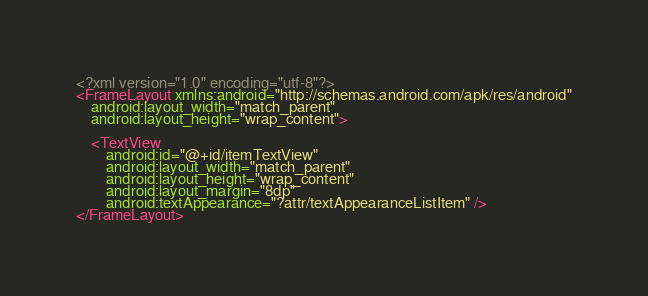Convert code to text. <code><loc_0><loc_0><loc_500><loc_500><_XML_><?xml version="1.0" encoding="utf-8"?>
<FrameLayout xmlns:android="http://schemas.android.com/apk/res/android"
    android:layout_width="match_parent"
    android:layout_height="wrap_content">

    <TextView
        android:id="@+id/itemTextView"
        android:layout_width="match_parent"
        android:layout_height="wrap_content"
        android:layout_margin="8dp"
        android:textAppearance="?attr/textAppearanceListItem" />
</FrameLayout></code> 